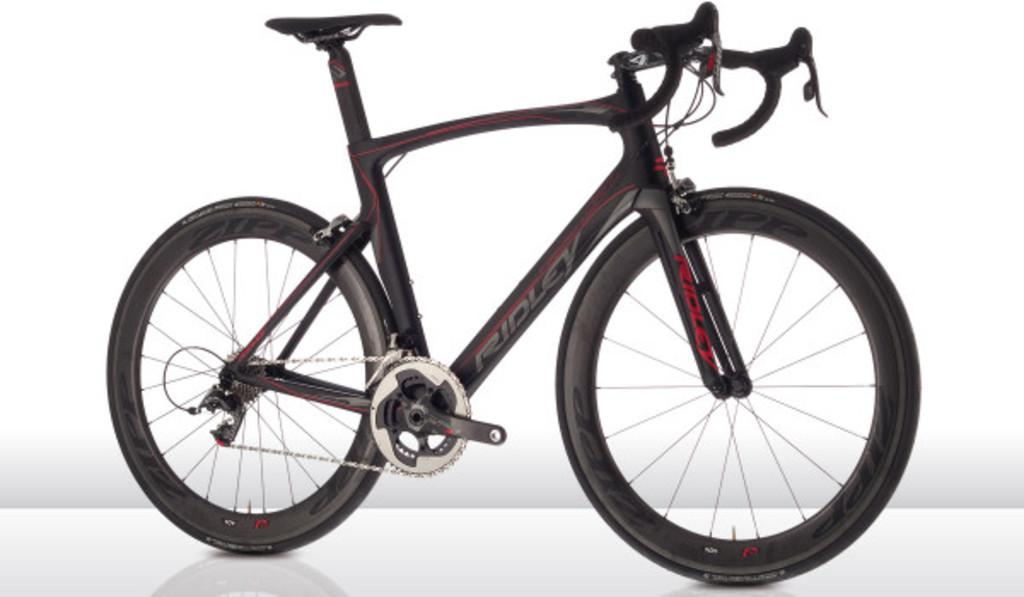What is the main subject of the picture? The main subject of the picture is a bicycle. What can be seen in the background of the image? The background of the image is white. What type of needle is being used by the army in the image? A: There is no army or needle present in the image; it features a bicycle with a white background. 